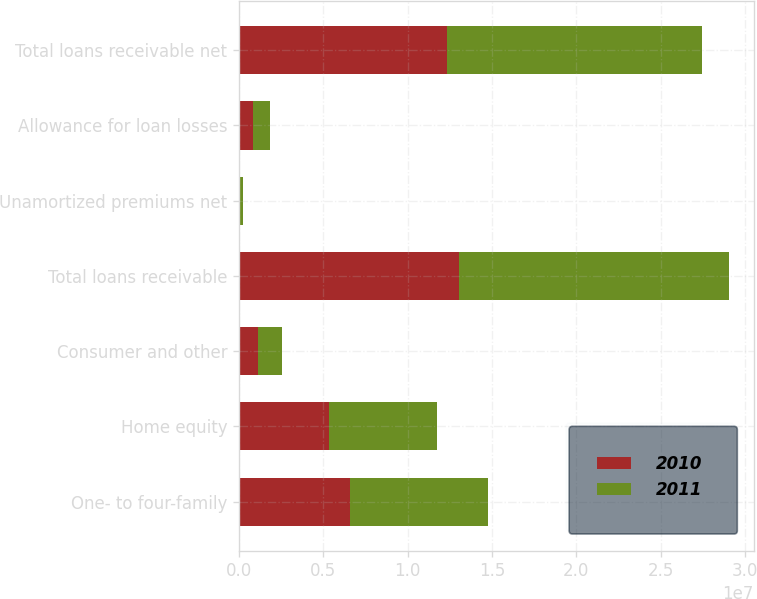Convert chart to OTSL. <chart><loc_0><loc_0><loc_500><loc_500><stacked_bar_chart><ecel><fcel>One- to four-family<fcel>Home equity<fcel>Consumer and other<fcel>Total loans receivable<fcel>Unamortized premiums net<fcel>Allowance for loan losses<fcel>Total loans receivable net<nl><fcel>2010<fcel>6.61581e+06<fcel>5.32866e+06<fcel>1.11326e+06<fcel>1.30577e+07<fcel>97901<fcel>822816<fcel>1.23328e+07<nl><fcel>2011<fcel>8.17033e+06<fcel>6.41031e+06<fcel>1.4434e+06<fcel>1.6024e+07<fcel>129050<fcel>1.03117e+06<fcel>1.51219e+07<nl></chart> 